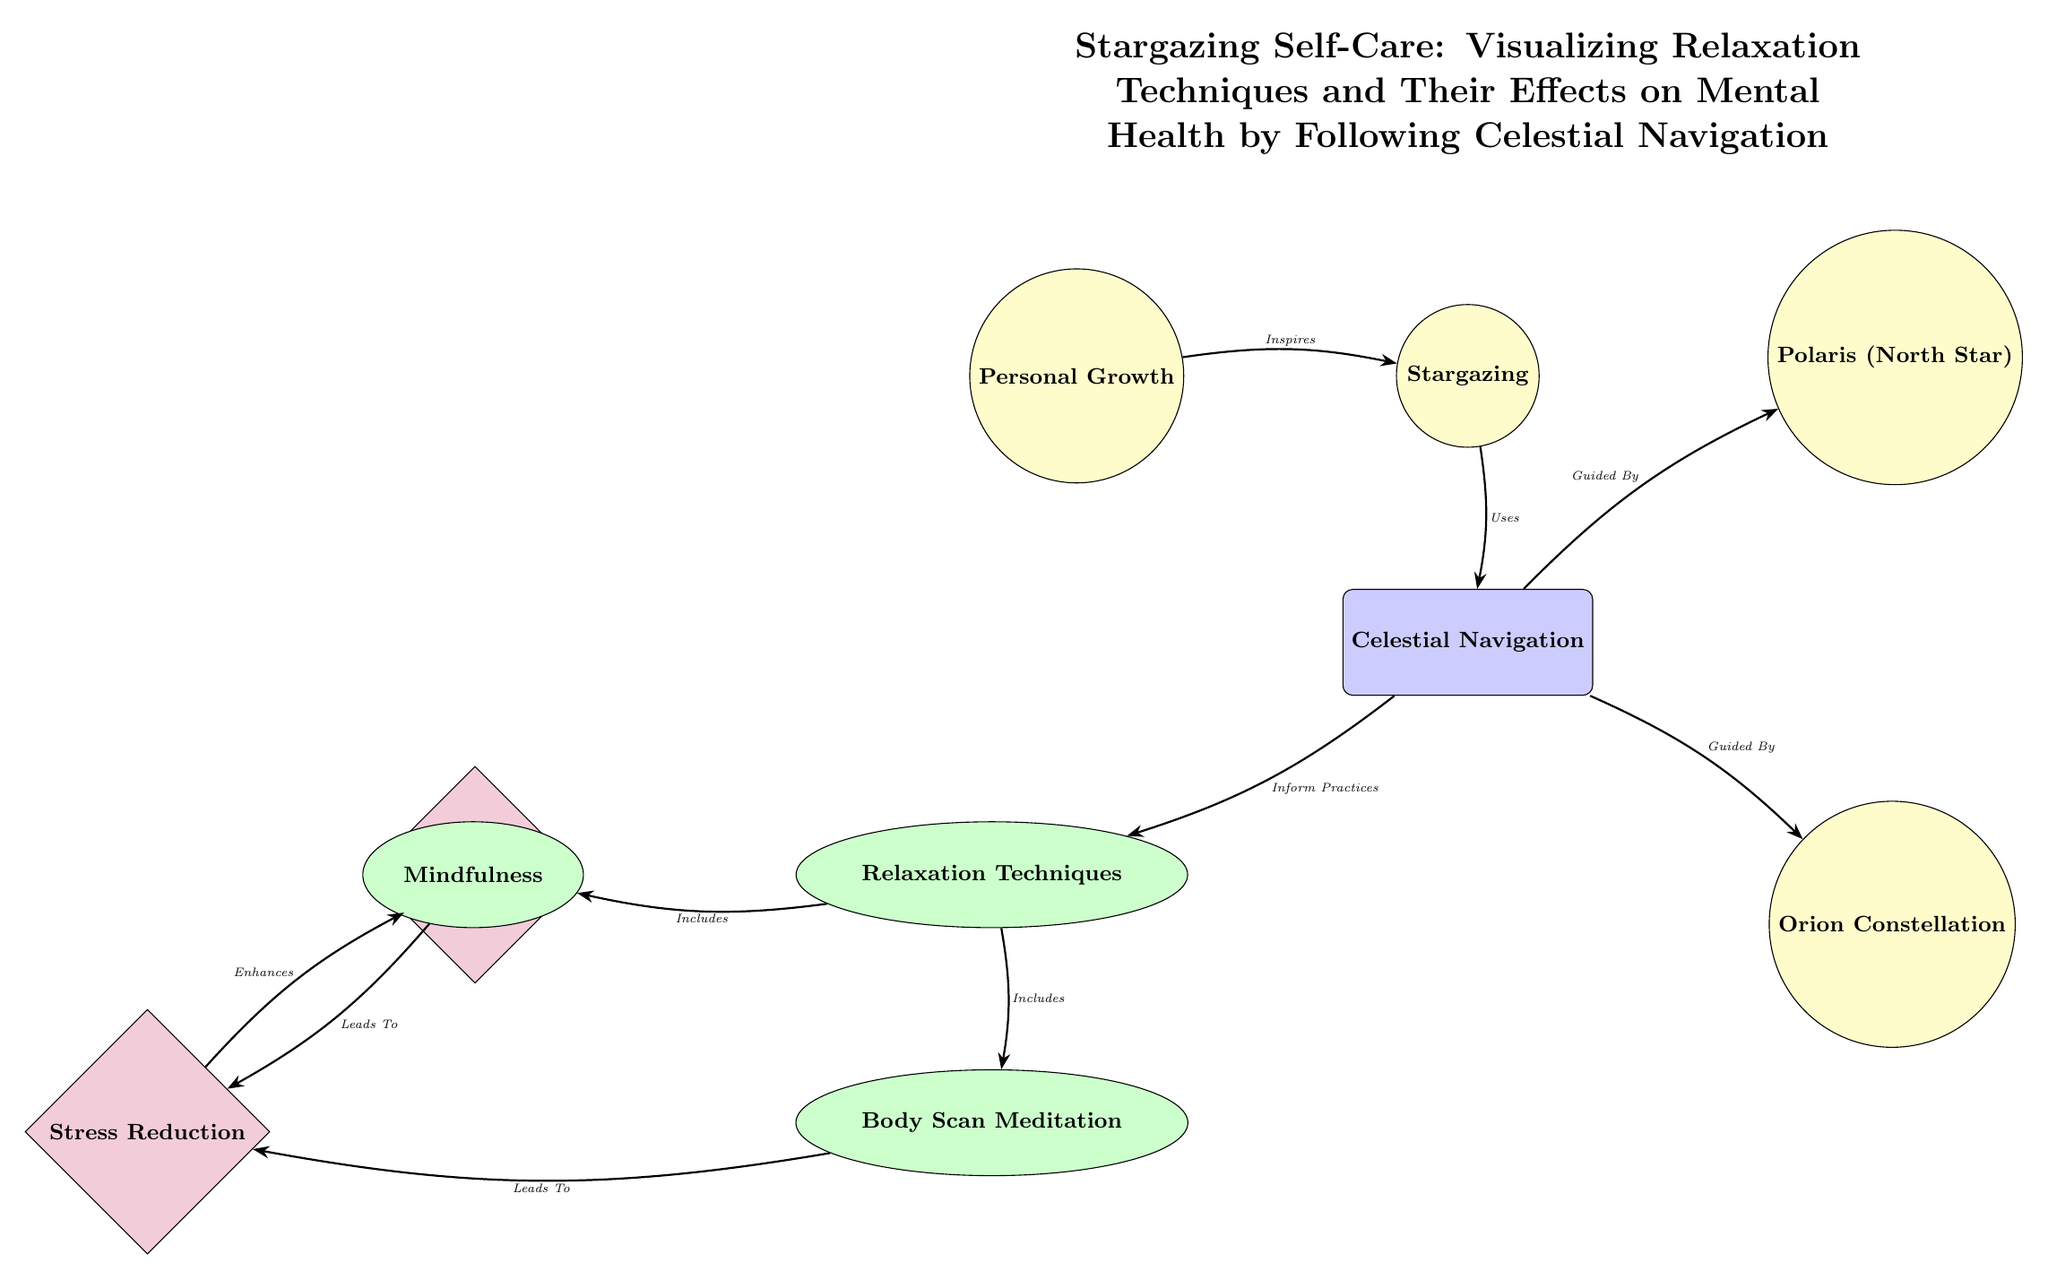What is the topmost node in the diagram? The topmost node in the diagram is labeled "Stargazing Self-Care: Visualizing Relaxation Techniques and Their Effects on Mental Health by Following Celestial Navigation." It is positioned directly above the node for "Stargazing."
Answer: Stargazing Self-Care: Visualizing Relaxation Techniques and Their Effects on Mental Health by Following Celestial Navigation How many relaxation techniques are listed in the diagram? The diagram shows two relaxation techniques listed as "Mindfulness" and "Body Scan Meditation" connected to the "Relaxation Techniques" node. Therefore, there are two techniques.
Answer: 2 What connects "Stargazing" to "Celestial Navigation"? The edge labeled "Uses" connects the node "Stargazing" to the node "Celestial Navigation," indicating the relationship between the two.
Answer: Uses What is the relationship between "Mindfulness" and "Stress Reduction"? The diagram indicates that "Mindfulness" leads to "Stress Reduction," showing a direct influence from the technique to the mental health outcome.
Answer: Leads To Which star is indicated as a guide in celestial navigation? The node "Polaris (North Star)" is indicated in the diagram as a guiding star in celestial navigation, connected by the edge labeled "Guided By."
Answer: Polaris (North Star) What color is used for the "Relaxation Techniques" node? The "Relaxation Techniques" node is filled with a green color, which distinguishes it from other types of nodes in the diagram.
Answer: Green Which node is directly below "Celestial Navigation"? The node directly below "Celestial Navigation" is "Relaxation Techniques," indicating a connection in the hierarchical structure of the diagram.
Answer: Relaxation Techniques What does "Mental Health" enhance according to the diagram? "Mental Health" is enhanced by "Stress Reduction," as indicated by the edge showing the relationship between these two nodes in the flow of information.
Answer: Enhances What connects the "Celestial Navigation" node to the "Polaris" node? The edge labeled "Guided By" connects "Celestial Navigation" to the "Polaris (North Star)" node, indicating that celestial navigation is guided by this star.
Answer: Guided By 